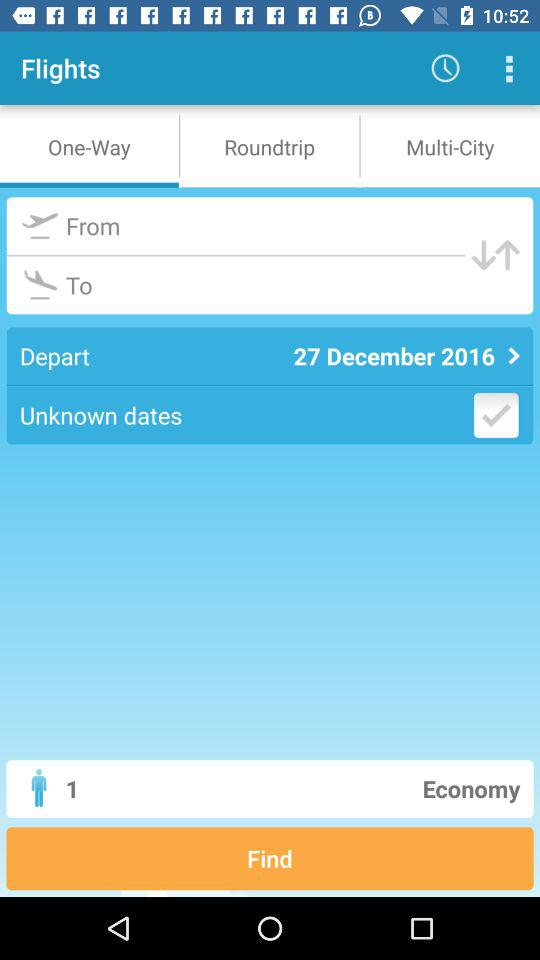What is the travelling class? The travelling class is economy. 